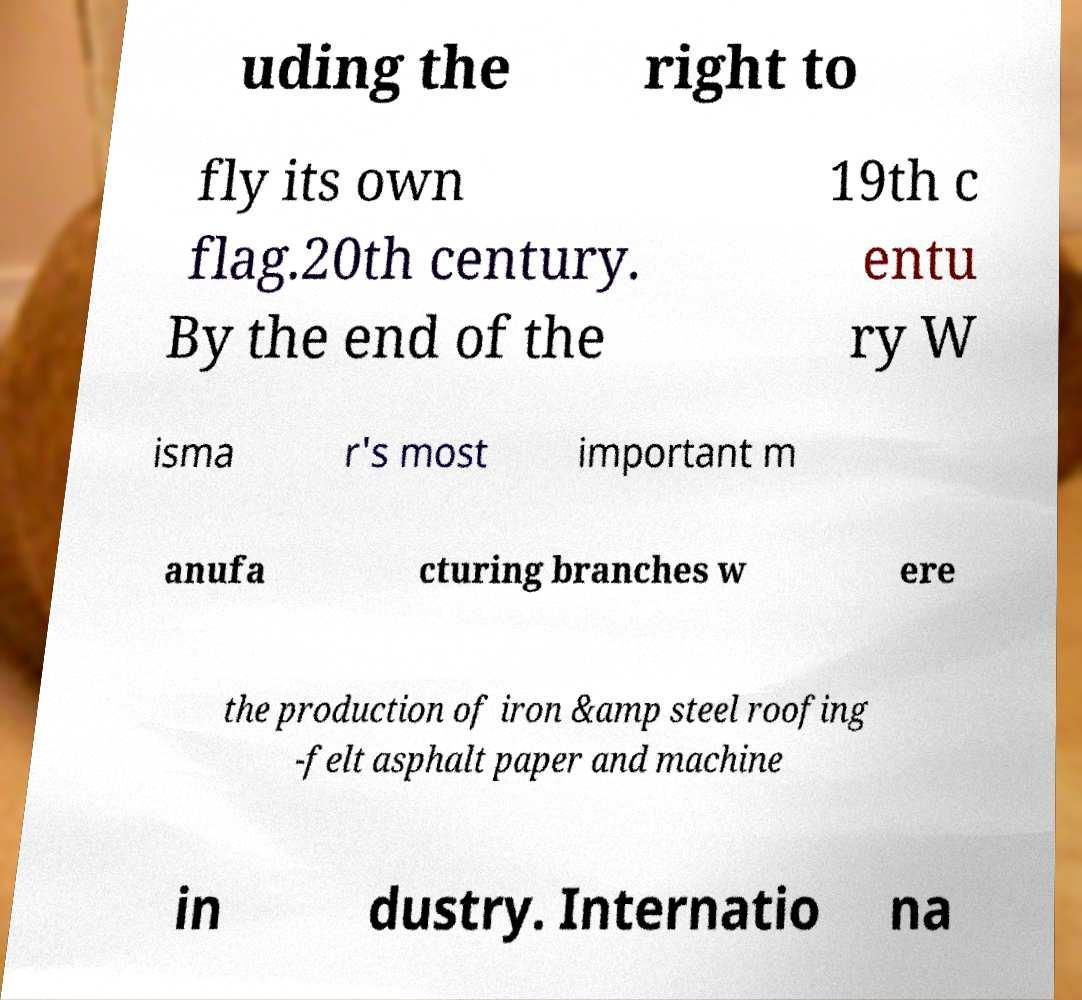Please read and relay the text visible in this image. What does it say? uding the right to fly its own flag.20th century. By the end of the 19th c entu ry W isma r's most important m anufa cturing branches w ere the production of iron &amp steel roofing -felt asphalt paper and machine in dustry. Internatio na 